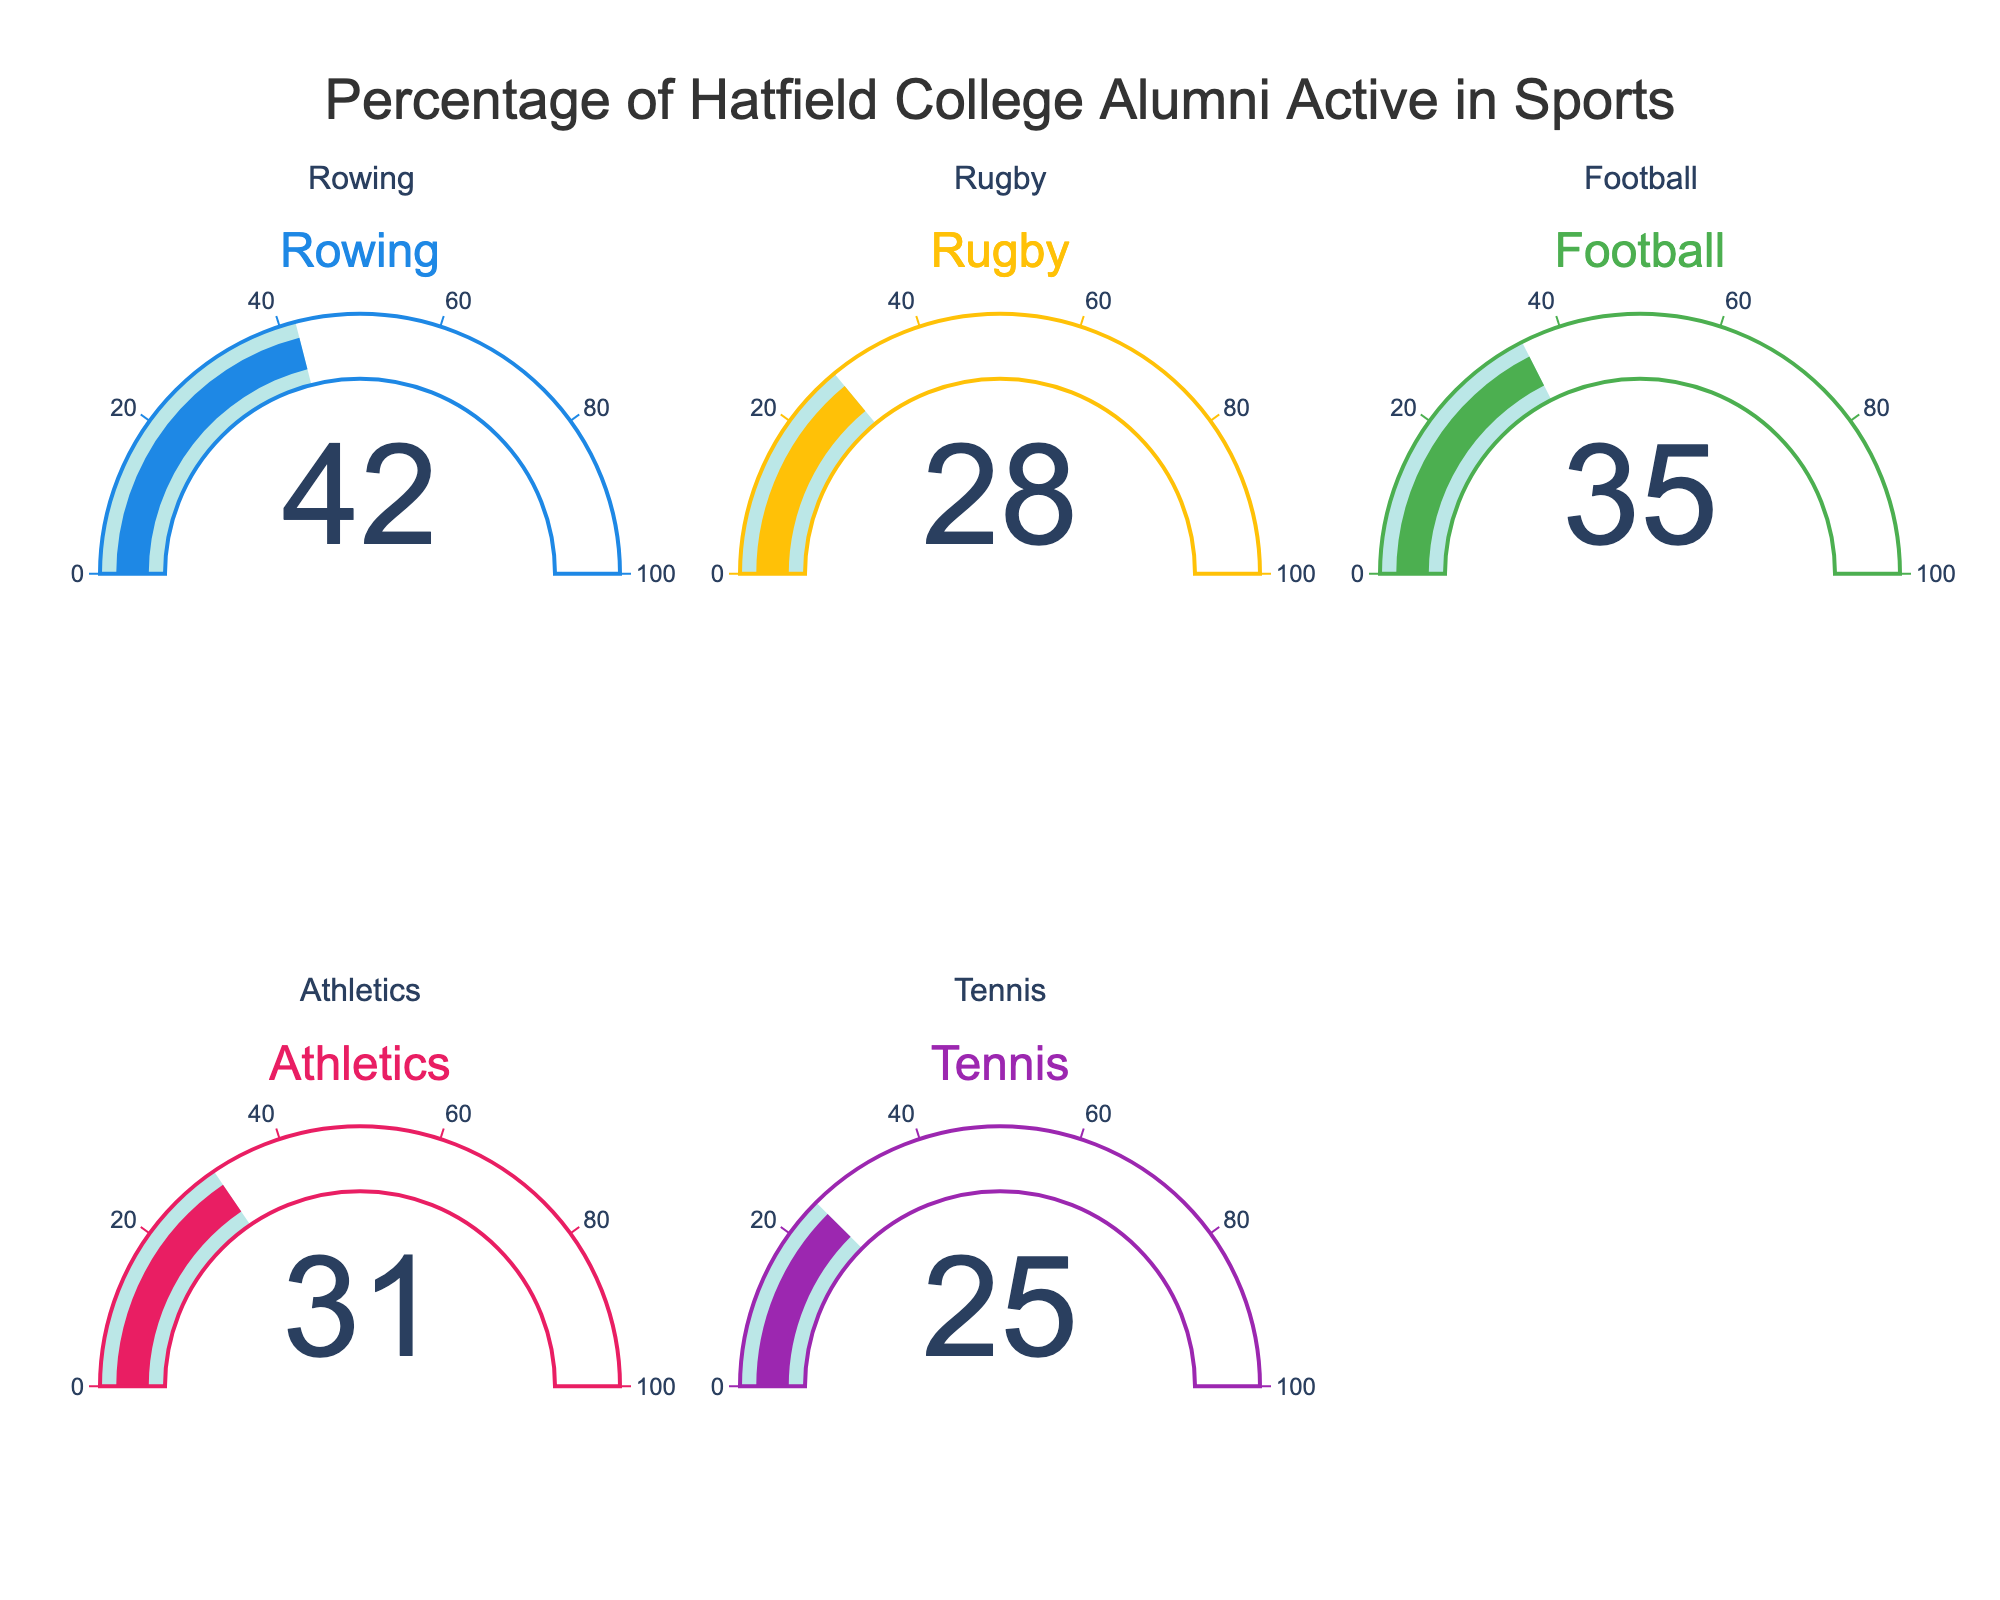What's the title of the figure? The title is usually displayed at the top of the figure in larger and bolder font. It summarizes the main data presented.
Answer: Percentage of Hatfield College Alumni Active in Sports How many sports are represented in the figure? To determine this, you need to count the number of gauge charts displayed. Each gauge chart corresponds to a sport.
Answer: 5 Which sport has the highest percentage of alumni remaining active? Look at each gauge chart's value and identify the highest one.
Answer: Rowing Which sport has the lowest percentage of alumni remaining active? Look at each gauge chart's value and identify the lowest one.
Answer: Tennis What's the average percentage of alumni remaining active across all sports? Add up the percentages of all sports and divide by the total number of sports: (42 + 28 + 35 + 31 + 25) / 5 = 161 / 5.
Answer: 32.2 What's the difference in the percentage of alumni remaining active between Rowing and Rugby? Subtract the Rugby percentage from the Rowing percentage: 42 - 28.
Answer: 14 Is the percentage of alumni active in Football greater than the percentage of alumni active in Athletics? Compare the percentages of Football and Athletics.
Answer: Yes Which sports have percentages within 5% of each other? Compare the percentages of all sports pairs to check whether their differences are within ±5%. For instance, the difference between Football (35) and Athletics (31) is 4.
Answer: Football and Athletics If the percentage for Tennis increased by 10%, what would it be? Add 10% to the current Tennis percentage: 25 + 10.
Answer: 35 Is any sport's alumni activity percentage exactly equal to the average percentage of all sports? Calculate the average percentage and check if any sport has this exact value. The average is 32.2, and no sport has this exact value.
Answer: No 